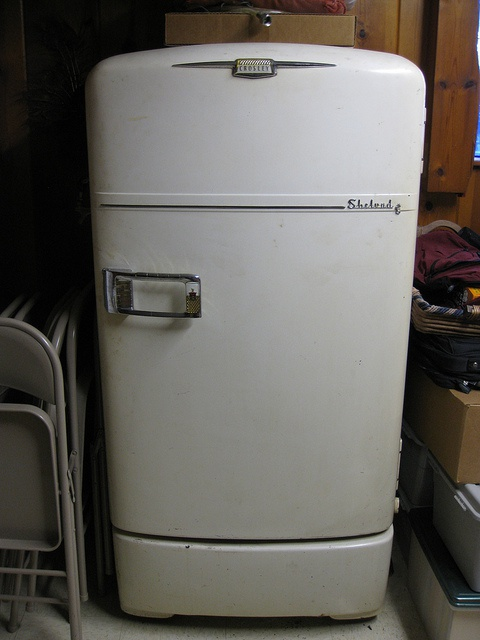Describe the objects in this image and their specific colors. I can see refrigerator in black, darkgray, gray, and lightgray tones, chair in black and gray tones, chair in black and gray tones, chair in black tones, and chair in black and gray tones in this image. 